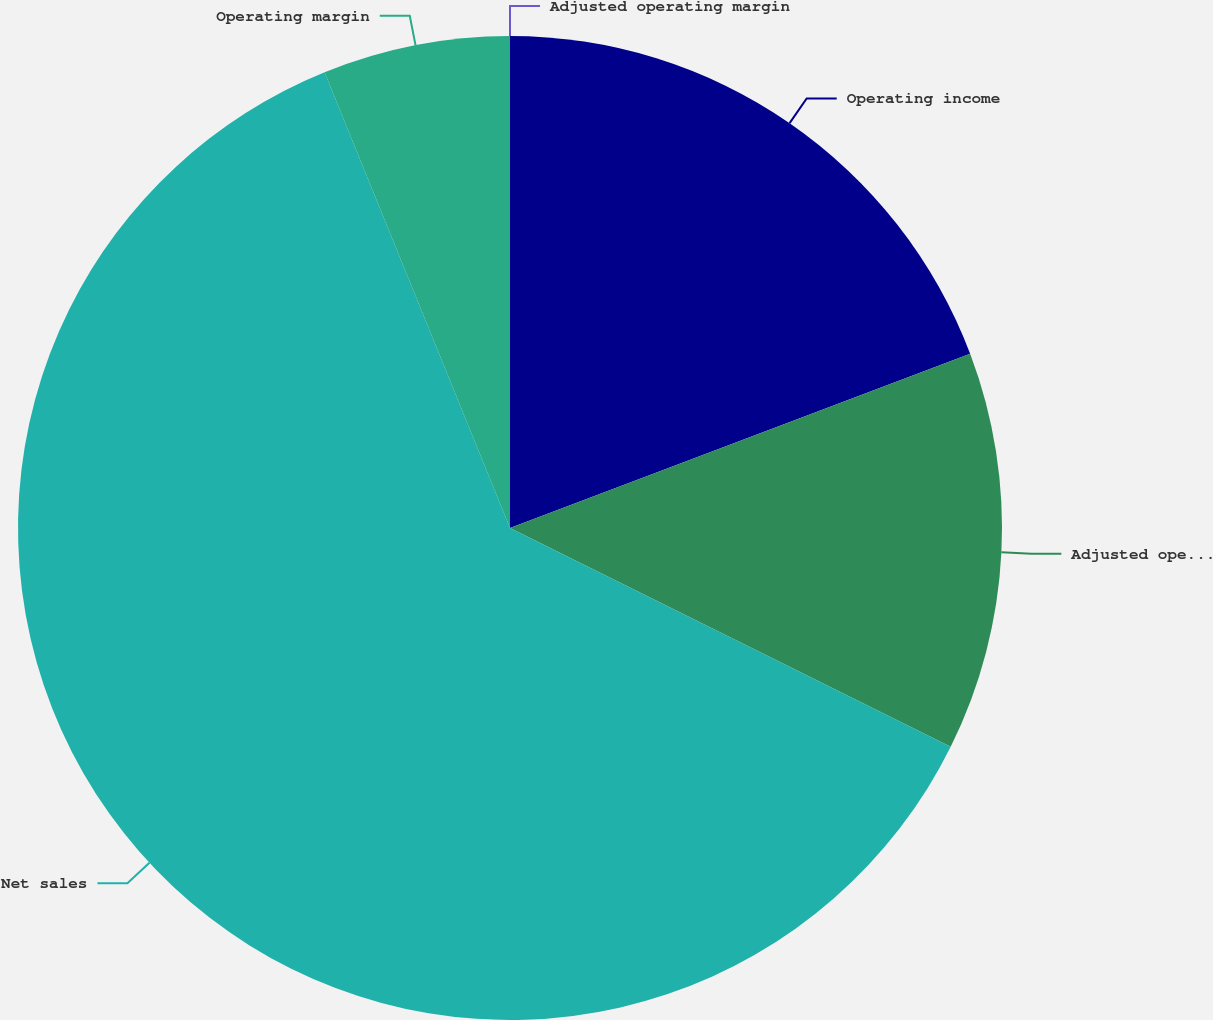<chart> <loc_0><loc_0><loc_500><loc_500><pie_chart><fcel>Operating income<fcel>Adjusted operating income<fcel>Net sales<fcel>Operating margin<fcel>Adjusted operating margin<nl><fcel>19.24%<fcel>13.09%<fcel>61.51%<fcel>6.15%<fcel>0.0%<nl></chart> 